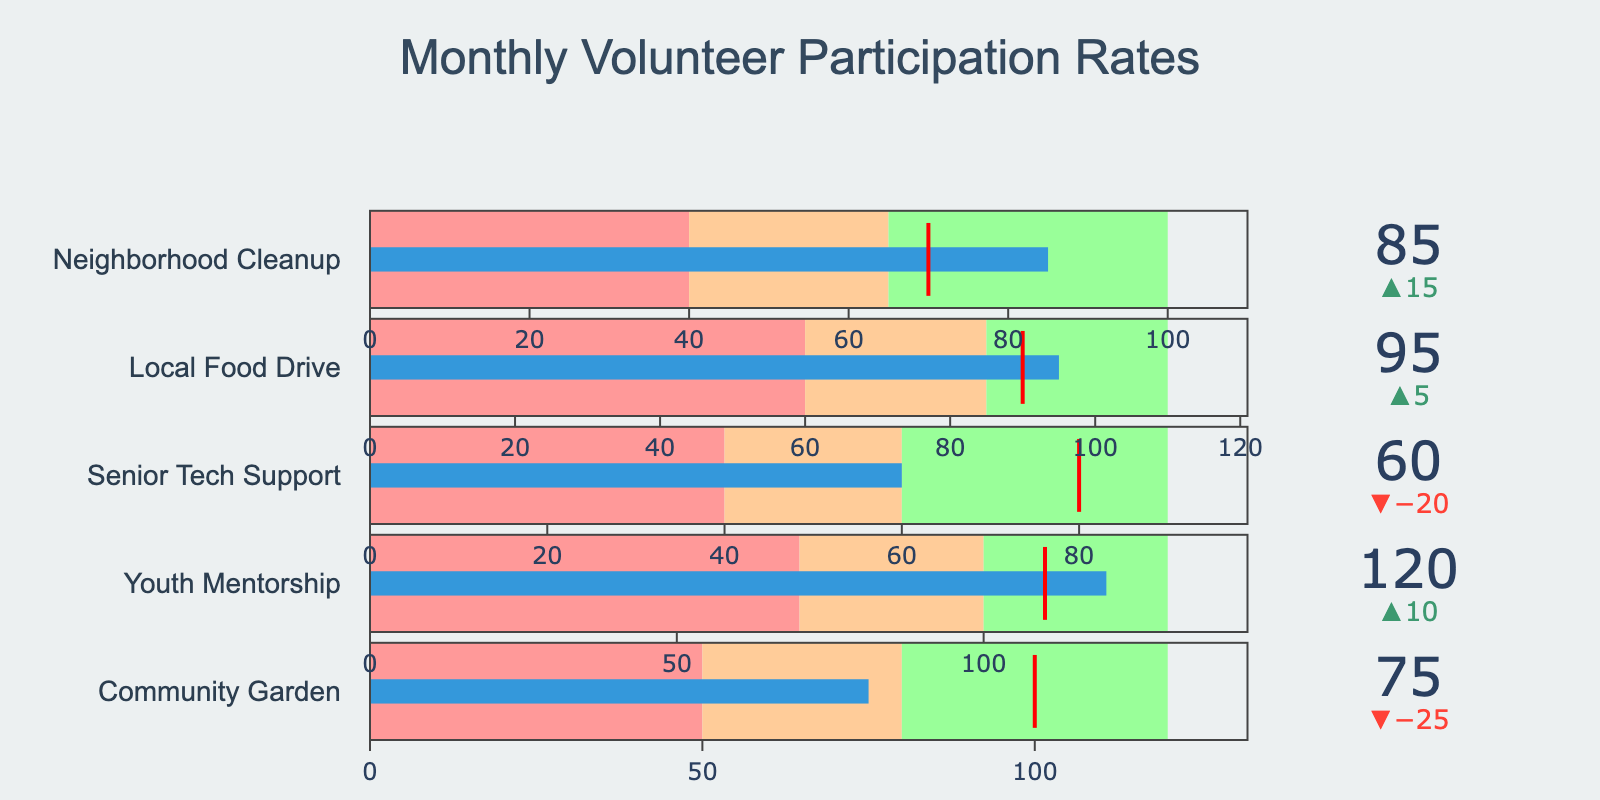What's the title of the figure? The title is typically displayed at the top of the chart and it summarizes the content of the figure.
Answer: Monthly Volunteer Participation Rates How many community projects are listed in the figure? Each project is represented by a separate bullet chart within the figure. By counting the individual bullet charts, we can determine the number of projects.
Answer: 5 What is the participation goal for the Youth Mentorship project? The goal for each project is denoted by a threshold line in the bullet chart, which is also specified in the data table. For the Youth Mentorship project, this value is given directly.
Answer: 110 Which project has the highest actual participation rate? The actual participation rates can be observed from the bullet charts. By comparing the actual values for each project, we identify the one with the highest value.
Answer: Youth Mentorship Is the Community Garden project meeting its participation goal? To determine if it meets the goal, compare the actual participation rate with the goal line in the bullet chart. If it meets or exceeds the goal, the answer is yes; otherwise, no.
Answer: No What's the difference between the actual and goal participation rates for the Local Food Drive? To find the difference, subtract the goal participation rate from the actual participation rate for the Local Food Drive project.
Answer: 5 Which project has an actual participation rate in the high range? The high range is indicated in green on the bullet chart. By identifying which project’s actual rate falls within this green area, we can answer the question.
Answer: None For which project is the actual participation rate below the low range? The low range is indicated by the red segment on the bullet chart. By checking which project's actual value falls within this red segment, we find the answer.
Answer: Senior Tech Support Between the Community Garden and Neighborhood Cleanup projects, which one is closer to its goal? Calculate the absolute difference between the actual and goal participation rates for both projects and compare these differences.
Answer: Neighborhood Cleanup What's the total actual participation for all the projects combined? Add the actual participation rates for all projects: Community Garden (75), Youth Mentorship (120), Senior Tech Support (60), Local Food Drive (95), Neighborhood Cleanup (85).
Answer: 435 